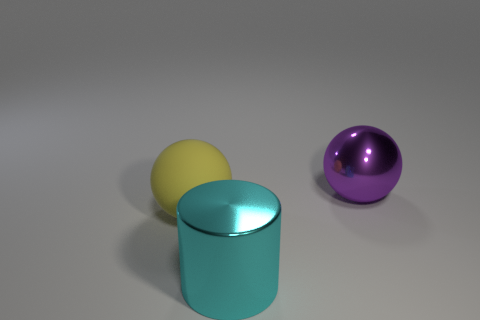Add 2 big purple metal objects. How many objects exist? 5 Subtract all balls. How many objects are left? 1 Add 1 big yellow balls. How many big yellow balls exist? 2 Subtract 0 green spheres. How many objects are left? 3 Subtract all metal spheres. Subtract all cyan things. How many objects are left? 1 Add 3 cyan cylinders. How many cyan cylinders are left? 4 